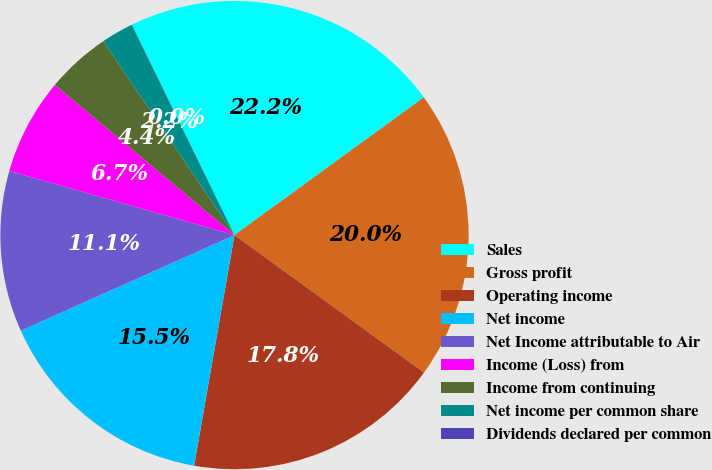<chart> <loc_0><loc_0><loc_500><loc_500><pie_chart><fcel>Sales<fcel>Gross profit<fcel>Operating income<fcel>Net income<fcel>Net Income attributable to Air<fcel>Income (Loss) from<fcel>Income from continuing<fcel>Net income per common share<fcel>Dividends declared per common<nl><fcel>22.22%<fcel>20.0%<fcel>17.77%<fcel>15.55%<fcel>11.11%<fcel>6.67%<fcel>4.45%<fcel>2.23%<fcel>0.01%<nl></chart> 